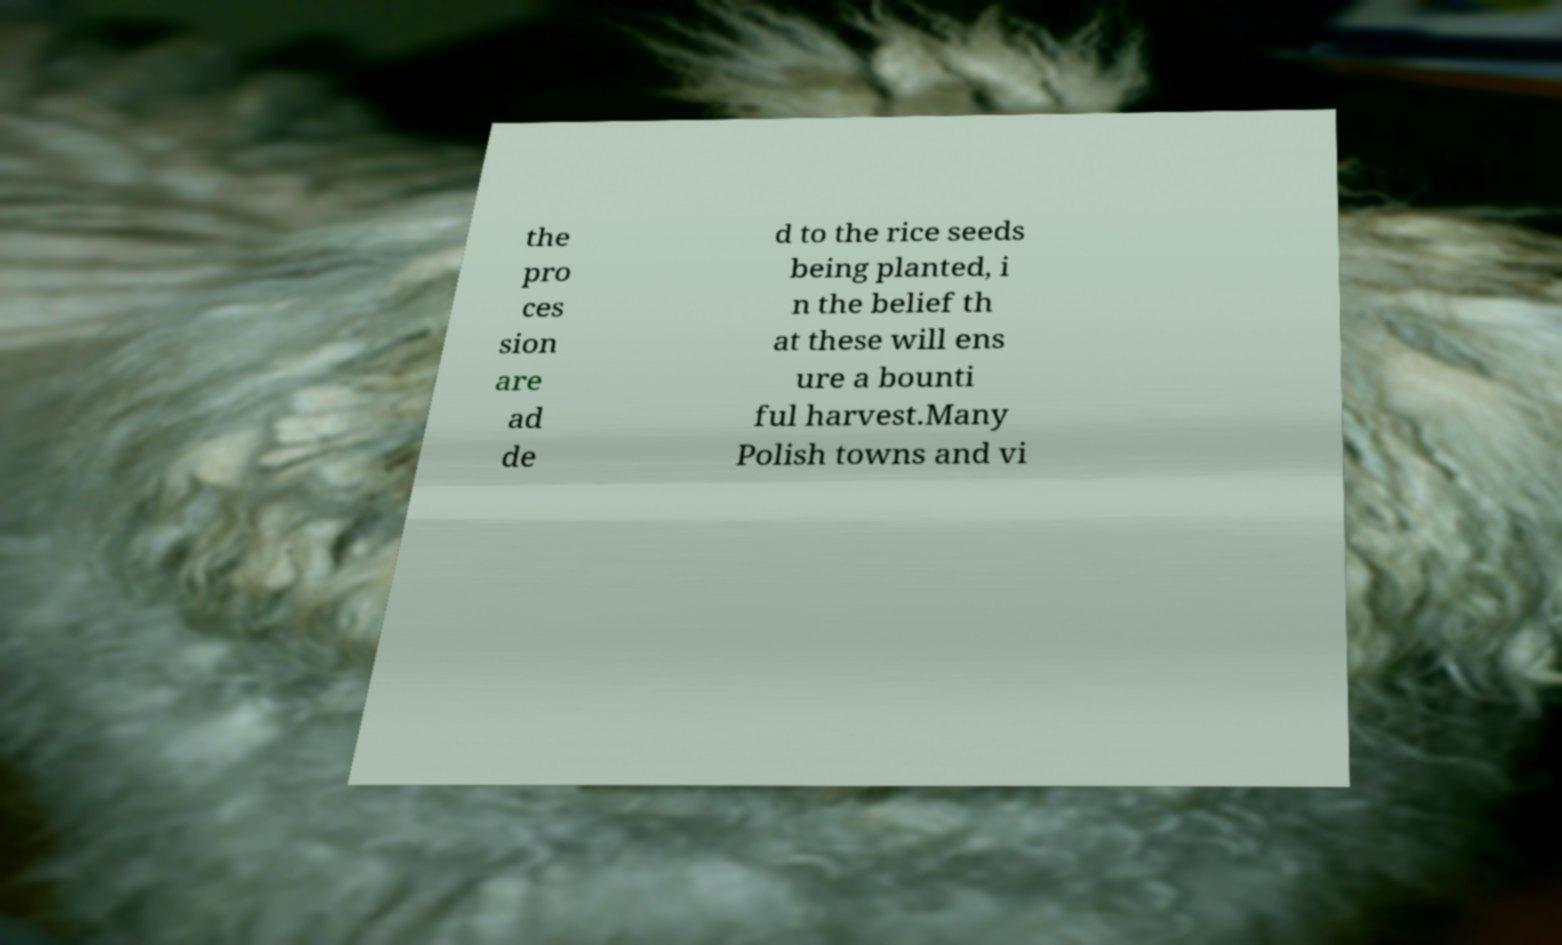Please read and relay the text visible in this image. What does it say? the pro ces sion are ad de d to the rice seeds being planted, i n the belief th at these will ens ure a bounti ful harvest.Many Polish towns and vi 